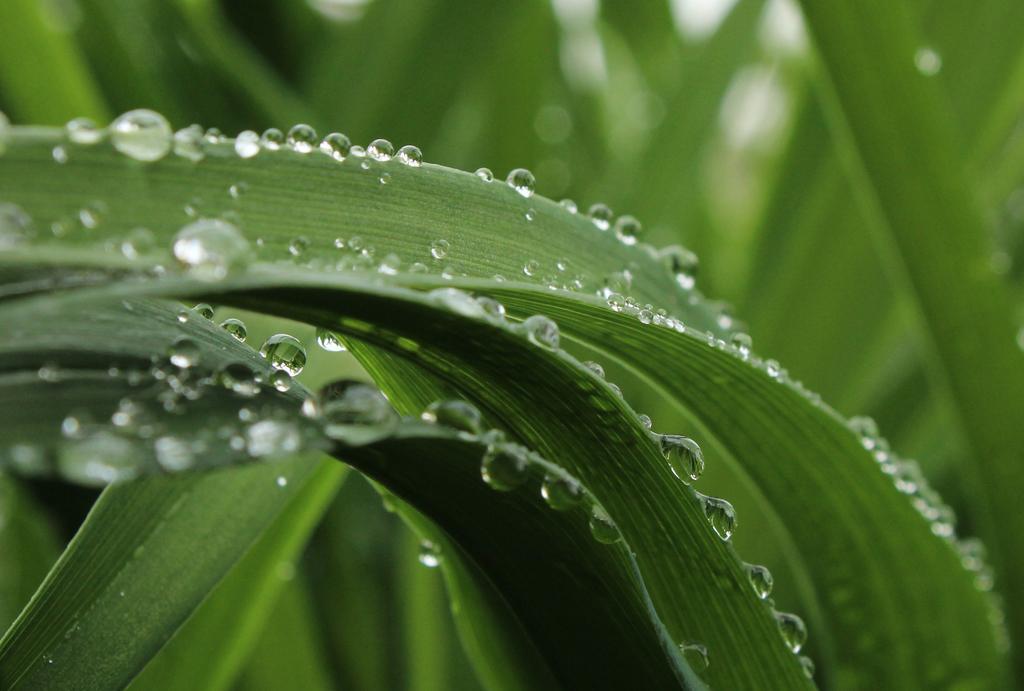Describe this image in one or two sentences. In this image we can see some leaves with water droplets and the background is blurred. 